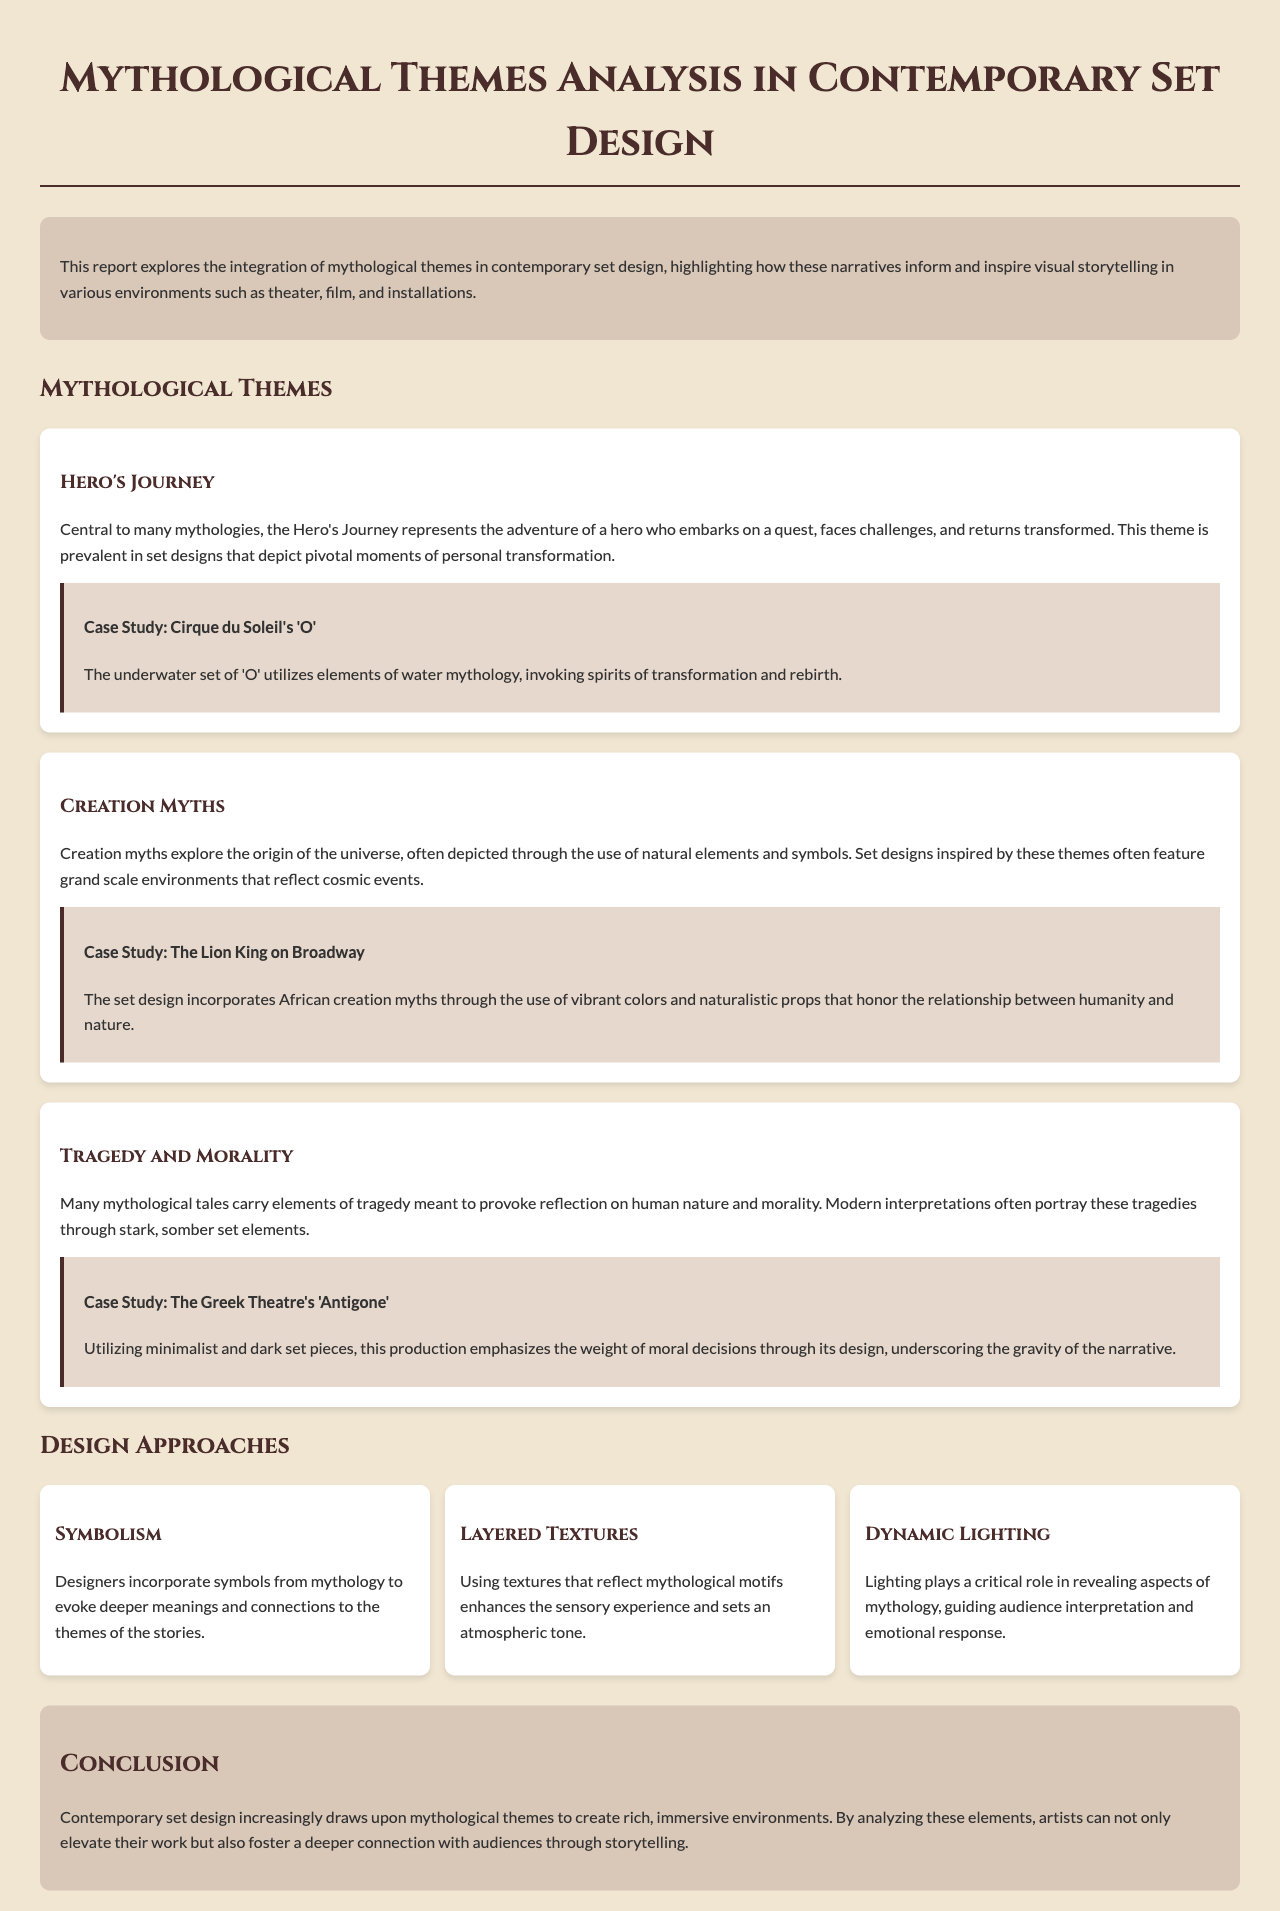What is the title of the report? The title of the report is stated at the top of the document.
Answer: Mythological Themes Analysis in Contemporary Set Design What theme is central to many mythologies? The theme is mentioned within the section about mythological themes.
Answer: Hero's Journey What is the case study mentioned for the Hero's Journey theme? The case study is given as an example in the document.
Answer: Cirque du Soleil's 'O' Which set design incorporates African creation myths? The set design is referenced in the context of its cultural inspiration.
Answer: The Lion King on Broadway What design approach utilizes textures? This is one of the design approaches discussed in the report.
Answer: Layered Textures What is the primary focus of the conclusion? The conclusion summarizes the main takeaway from the report.
Answer: Mythological themes in contemporary set design What type of lighting is emphasized for revealing mythology? The answer is specified among the three design approaches mentioned.
Answer: Dynamic Lighting Which Greek play's set design is highlighted for tragedy? The play is cited in a case study dealing with tragedy and morality.
Answer: Antigone What color scheme is used in the introduction section? The color scheme is indicated through the section's background description.
Answer: D9c7b8 (or "light brown") 